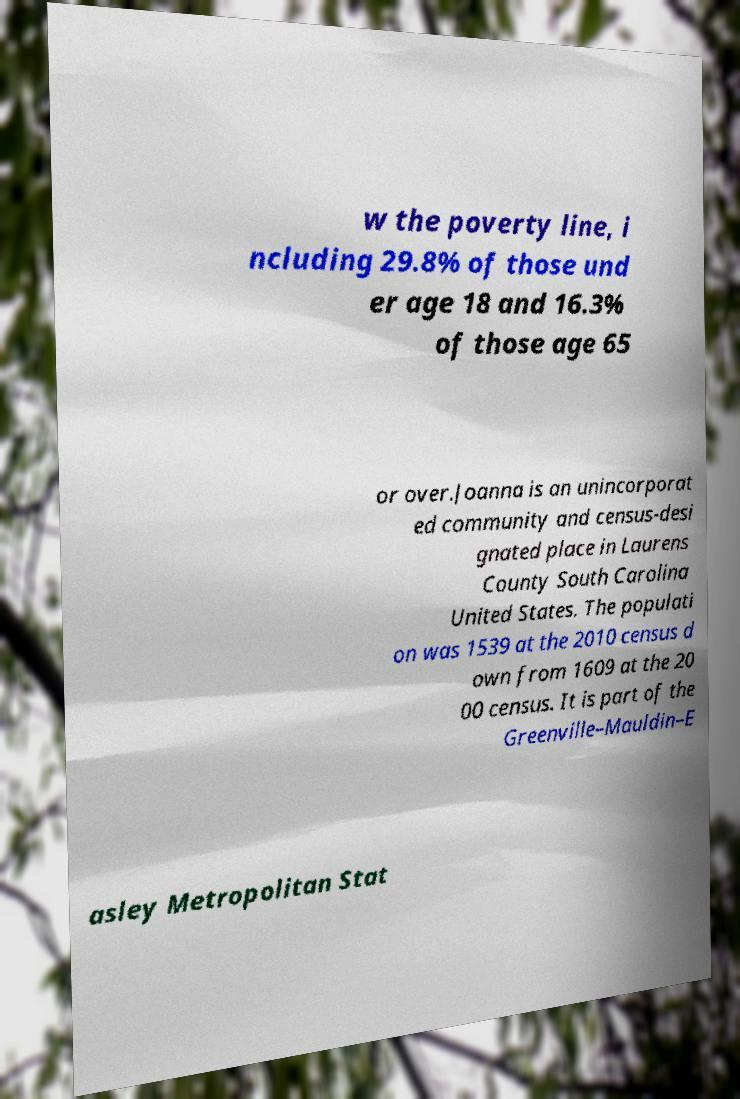What messages or text are displayed in this image? I need them in a readable, typed format. w the poverty line, i ncluding 29.8% of those und er age 18 and 16.3% of those age 65 or over.Joanna is an unincorporat ed community and census-desi gnated place in Laurens County South Carolina United States. The populati on was 1539 at the 2010 census d own from 1609 at the 20 00 census. It is part of the Greenville–Mauldin–E asley Metropolitan Stat 